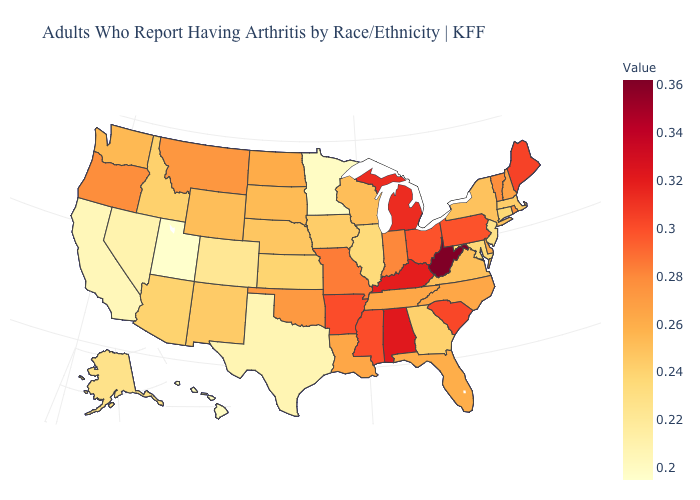Among the states that border New Hampshire , does Massachusetts have the lowest value?
Give a very brief answer. Yes. Which states have the lowest value in the South?
Concise answer only. Texas. Which states have the highest value in the USA?
Give a very brief answer. West Virginia. Does West Virginia have the highest value in the South?
Answer briefly. Yes. Does Oregon have a higher value than Nebraska?
Give a very brief answer. Yes. Among the states that border Michigan , does Wisconsin have the lowest value?
Answer briefly. Yes. Which states hav the highest value in the South?
Answer briefly. West Virginia. Does Rhode Island have the highest value in the Northeast?
Answer briefly. No. 